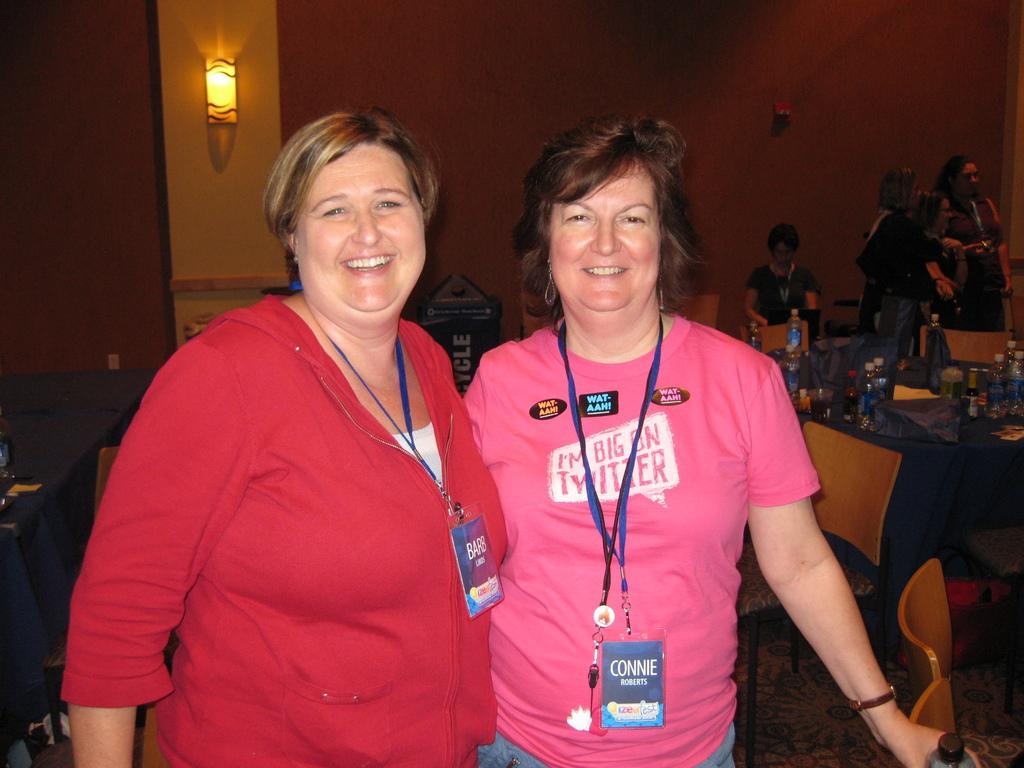Please provide a concise description of this image. In this image in the foreground there are two women visible , one woman holding a bottle, in the background there is the wall, in front of the wall there are few peoples visible, on the right side there is a table, on which there are few bottles, in front of table there are few chairs, on the beam a light attached visible on the left side, on the left side there is another table. 